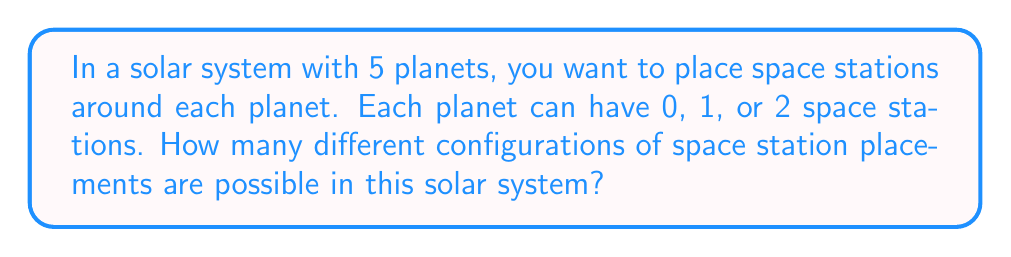Could you help me with this problem? Let's approach this step-by-step:

1) For each planet, we have 3 options: 0 stations, 1 station, or 2 stations.

2) This is a case of independent events. For each planet, we make a choice independently of the others.

3) When we have independent events, we use the multiplication principle.

4) The multiplication principle states that if we have $n$ independent events, and each event $i$ has $k_i$ possible outcomes, then the total number of possible outcomes is the product of all $k_i$.

5) In this case, we have 5 planets (events), and each has 3 possible outcomes.

6) Therefore, the total number of possible configurations is:

   $$3 \times 3 \times 3 \times 3 \times 3 = 3^5$$

7) We can calculate this:

   $$3^5 = 3 \times 3 \times 3 \times 3 \times 3 = 243$$

Thus, there are 243 different possible configurations of space station placements in this solar system.
Answer: $243$ 